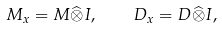<formula> <loc_0><loc_0><loc_500><loc_500>M _ { x } = M \widehat { \otimes } I , \quad D _ { x } = D \widehat { \otimes } I ,</formula> 